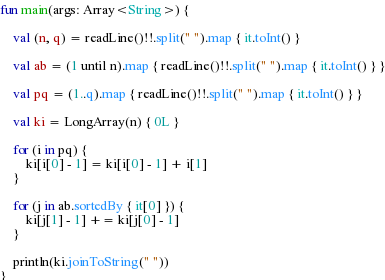<code> <loc_0><loc_0><loc_500><loc_500><_Kotlin_>fun main(args: Array<String>) {

    val (n, q) = readLine()!!.split(" ").map { it.toInt() }

    val ab = (1 until n).map { readLine()!!.split(" ").map { it.toInt() } }

    val pq = (1..q).map { readLine()!!.split(" ").map { it.toInt() } }

    val ki = LongArray(n) { 0L }

    for (i in pq) {
        ki[i[0] - 1] = ki[i[0] - 1] + i[1]
    }

    for (j in ab.sortedBy { it[0] }) {
        ki[j[1] - 1] += ki[j[0] - 1]
    }

    println(ki.joinToString(" "))
}
</code> 